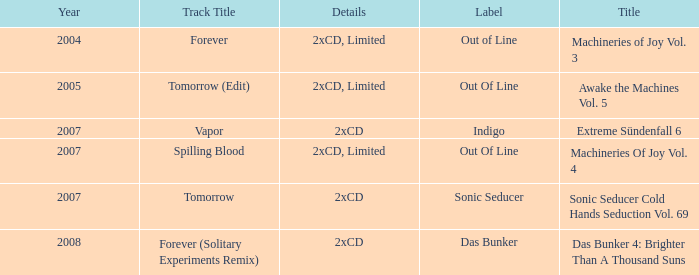Which track title has a year lesser thsn 2005? Forever. 